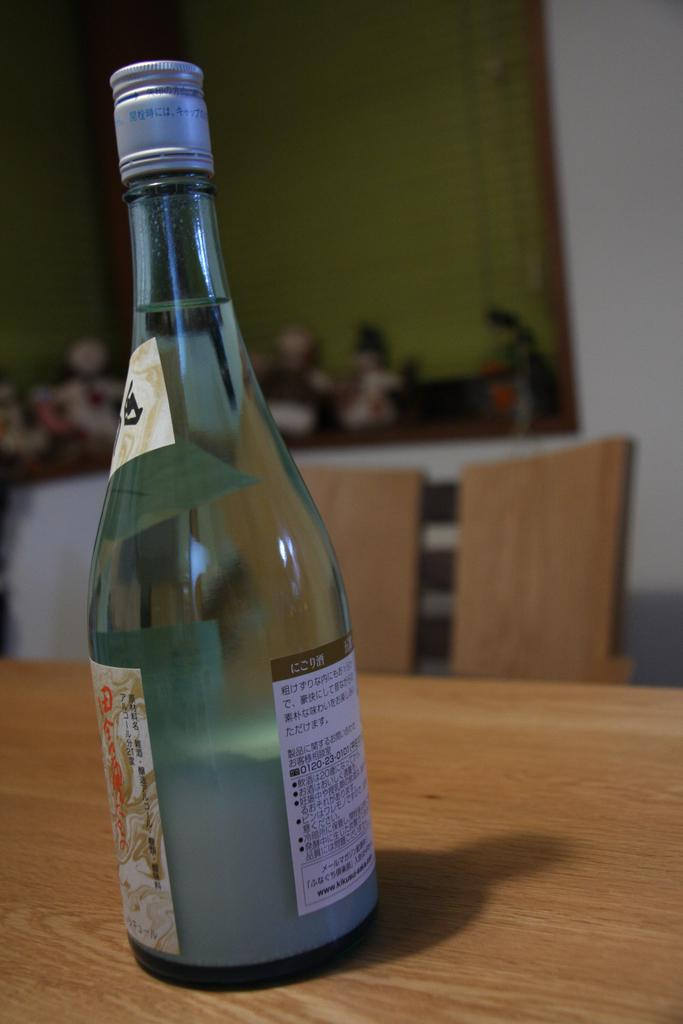What is on the table in the image? There is a wine bottle on the table. Can you describe the background of the image? The background of the image is blurry. How many friends does the beggar have in the image? There is no beggar or friend present in the image. 